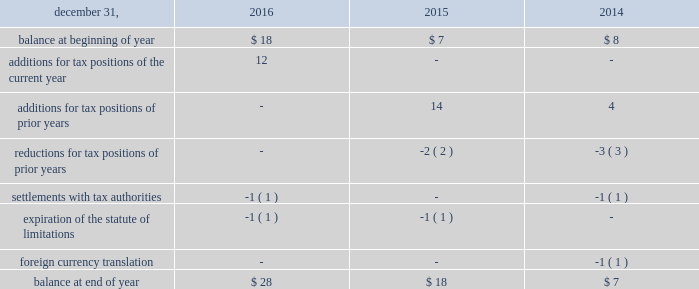Arconic and its subsidiaries file income tax returns in the u.s .
Federal jurisdiction and various states and foreign jurisdictions .
With a few minor exceptions , arconic is no longer subject to income tax examinations by tax authorities for years prior to 2006 .
All u.s .
Tax years prior to 2016 have been audited by the internal revenue service .
Various state and foreign jurisdiction tax authorities are in the process of examining arconic 2019s income tax returns for various tax years through 2015 .
A reconciliation of the beginning and ending amount of unrecognized tax benefits ( excluding interest and penalties ) was as follows: .
For all periods presented , a portion of the balance at end of year pertains to state tax liabilities , which are presented before any offset for federal tax benefits .
The effect of unrecognized tax benefits , if recorded , that would impact the annual effective tax rate for 2016 , 2015 , and 2014 would be approximately 6% ( 6 % ) , 7% ( 7 % ) , and 4% ( 4 % ) , respectively , of pretax book income .
Arconic does not anticipate that changes in its unrecognized tax benefits will have a material impact on the statement of consolidated operations during 2017 ( see tax in note l for a matter for which no reserve has been recognized ) .
It is arconic 2019s policy to recognize interest and penalties related to income taxes as a component of the provision for income taxes on the accompanying statement of consolidated operations .
In 2016 , 2015 , and 2014 , arconic did not recognize any interest or penalties .
Due to the expiration of the statute of limitations , settlements with tax authorities , and refunded overpayments , arconic recognized interest income of $ 1 in 2015 but did not recognize any interest income in 2016 or 2014 .
As of december 31 , 2016 and 2015 , the amount accrued for the payment of interest and penalties was $ 2 and $ 1 , respectively .
Receivables sale of receivables programs arconic has an arrangement with three financial institutions to sell certain customer receivables without recourse on a revolving basis .
The sale of such receivables is completed through the use of a bankruptcy remote special purpose entity , which is a consolidated subsidiary of arconic .
This arrangement provides for minimum funding of $ 200 up to a maximum of $ 400 for receivables sold .
On march 30 , 2012 , arconic initially sold $ 304 of customer receivables in exchange for $ 50 in cash and $ 254 of deferred purchase price under this arrangement .
Arconic has received additional net cash funding of $ 300 for receivables sold ( $ 1758 in draws and $ 1458 in repayments ) since the program 2019s inception , including $ 100 ( $ 500 in draws and $ 400 in repayments ) in 2016 .
No draws or repayments occurred in 2015 .
As of december 31 , 2016 and 2015 , the deferred purchase price receivable was $ 83 and $ 249 , respectively , which was included in other receivables on the accompanying consolidated balance sheet .
The deferred purchase price receivable is reduced as collections of the underlying receivables occur ; however , as this is a revolving program , the sale of new receivables will result in an increase in the deferred purchase price receivable .
The net change in the deferred purchase price receivable was reflected in the ( increase ) decrease in receivables line item on the accompanying statement of consolidated cash flows .
This activity is reflected as an operating cash flow because the related customer receivables are the result of an operating activity with an insignificant , short-term interest rate risk. .
Considering the years 2014-2015 , what was the increase in the additions for tax positions of prior years , in dollars? 
Rationale: it is the variation between those two additions for tax positions of prior years' values .
Computations: (14 - 4)
Answer: 10.0. 